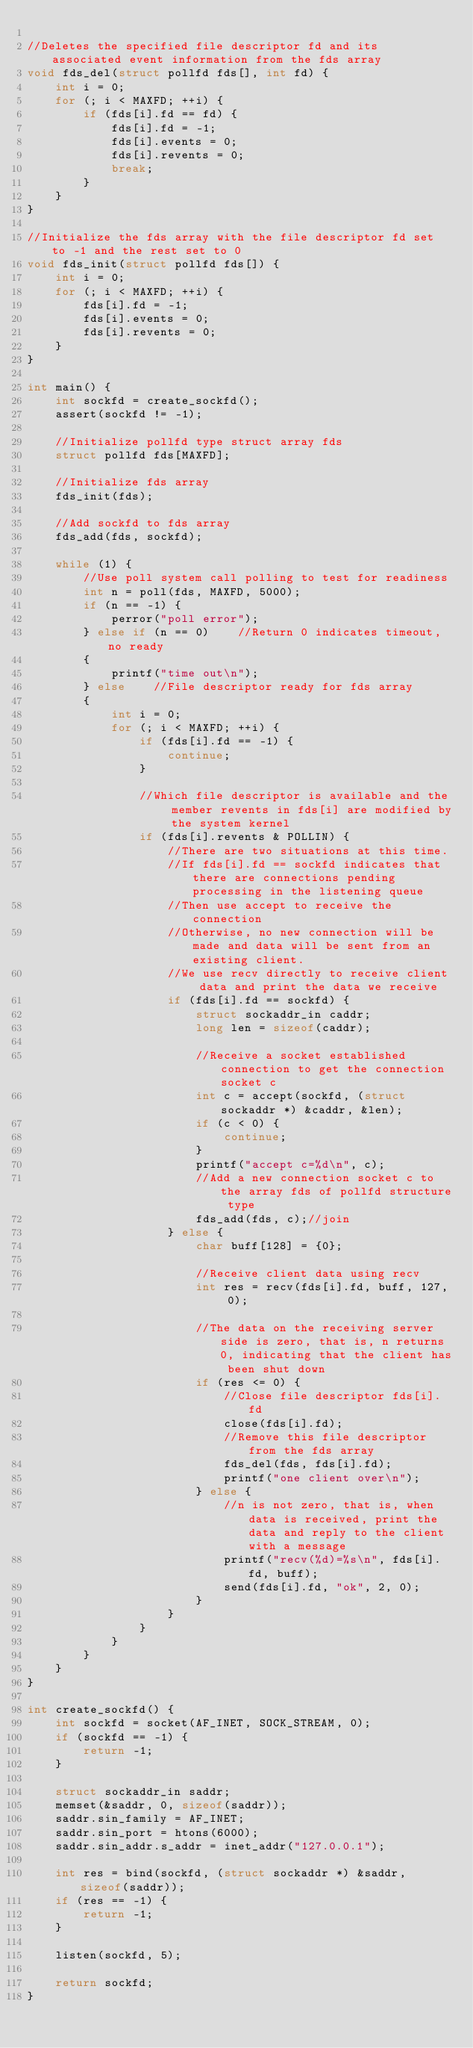Convert code to text. <code><loc_0><loc_0><loc_500><loc_500><_C_>
//Deletes the specified file descriptor fd and its associated event information from the fds array
void fds_del(struct pollfd fds[], int fd) {
    int i = 0;
    for (; i < MAXFD; ++i) {
        if (fds[i].fd == fd) {
            fds[i].fd = -1;
            fds[i].events = 0;
            fds[i].revents = 0;
            break;
        }
    }
}

//Initialize the fds array with the file descriptor fd set to -1 and the rest set to 0
void fds_init(struct pollfd fds[]) {
    int i = 0;
    for (; i < MAXFD; ++i) {
        fds[i].fd = -1;
        fds[i].events = 0;
        fds[i].revents = 0;
    }
}

int main() {
    int sockfd = create_sockfd();
    assert(sockfd != -1);

    //Initialize pollfd type struct array fds
    struct pollfd fds[MAXFD];

    //Initialize fds array
    fds_init(fds);

    //Add sockfd to fds array
    fds_add(fds, sockfd);

    while (1) {
        //Use poll system call polling to test for readiness
        int n = poll(fds, MAXFD, 5000);
        if (n == -1) {
            perror("poll error");
        } else if (n == 0)    //Return 0 indicates timeout, no ready
        {
            printf("time out\n");
        } else    //File descriptor ready for fds array
        {
            int i = 0;
            for (; i < MAXFD; ++i) {
                if (fds[i].fd == -1) {
                    continue;
                }

                //Which file descriptor is available and the member revents in fds[i] are modified by the system kernel
                if (fds[i].revents & POLLIN) {
                    //There are two situations at this time.
                    //If fds[i].fd == sockfd indicates that there are connections pending processing in the listening queue
                    //Then use accept to receive the connection
                    //Otherwise, no new connection will be made and data will be sent from an existing client.
                    //We use recv directly to receive client data and print the data we receive
                    if (fds[i].fd == sockfd) {
                        struct sockaddr_in caddr;
                        long len = sizeof(caddr);

                        //Receive a socket established connection to get the connection socket c
                        int c = accept(sockfd, (struct sockaddr *) &caddr, &len);
                        if (c < 0) {
                            continue;
                        }
                        printf("accept c=%d\n", c);
                        //Add a new connection socket c to the array fds of pollfd structure type
                        fds_add(fds, c);//join
                    } else {
                        char buff[128] = {0};

                        //Receive client data using recv
                        int res = recv(fds[i].fd, buff, 127, 0);

                        //The data on the receiving server side is zero, that is, n returns 0, indicating that the client has been shut down
                        if (res <= 0) {
                            //Close file descriptor fds[i].fd
                            close(fds[i].fd);
                            //Remove this file descriptor from the fds array
                            fds_del(fds, fds[i].fd);
                            printf("one client over\n");
                        } else {
                            //n is not zero, that is, when data is received, print the data and reply to the client with a message
                            printf("recv(%d)=%s\n", fds[i].fd, buff);
                            send(fds[i].fd, "ok", 2, 0);
                        }
                    }
                }
            }
        }
    }
}

int create_sockfd() {
    int sockfd = socket(AF_INET, SOCK_STREAM, 0);
    if (sockfd == -1) {
        return -1;
    }

    struct sockaddr_in saddr;
    memset(&saddr, 0, sizeof(saddr));
    saddr.sin_family = AF_INET;
    saddr.sin_port = htons(6000);
    saddr.sin_addr.s_addr = inet_addr("127.0.0.1");

    int res = bind(sockfd, (struct sockaddr *) &saddr, sizeof(saddr));
    if (res == -1) {
        return -1;
    }

    listen(sockfd, 5);

    return sockfd;
}
</code> 